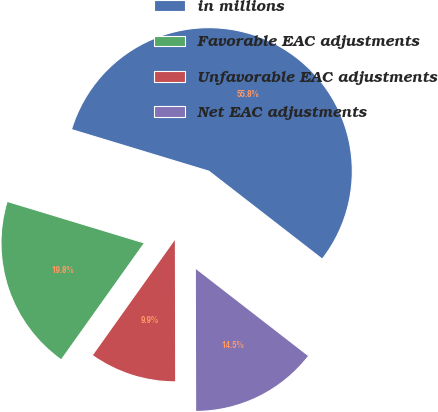<chart> <loc_0><loc_0><loc_500><loc_500><pie_chart><fcel>in millions<fcel>Favorable EAC adjustments<fcel>Unfavorable EAC adjustments<fcel>Net EAC adjustments<nl><fcel>55.81%<fcel>19.84%<fcel>9.88%<fcel>14.47%<nl></chart> 